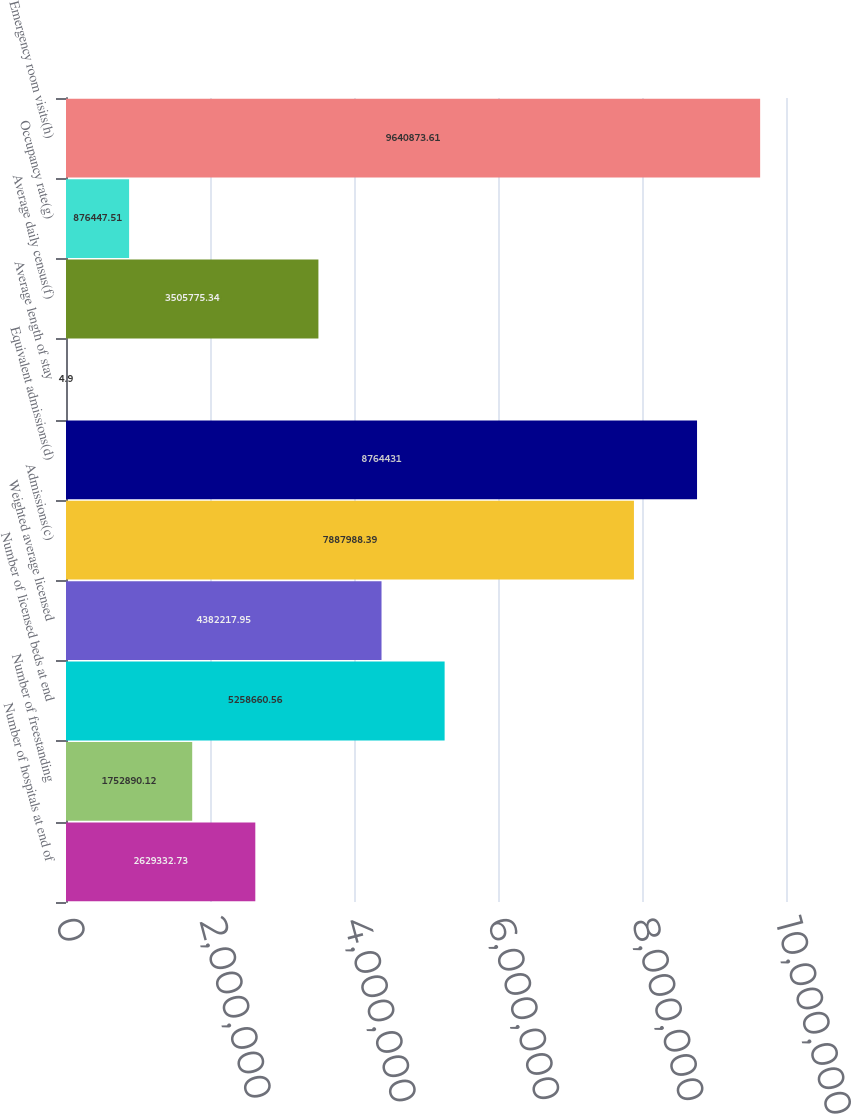<chart> <loc_0><loc_0><loc_500><loc_500><bar_chart><fcel>Number of hospitals at end of<fcel>Number of freestanding<fcel>Number of licensed beds at end<fcel>Weighted average licensed<fcel>Admissions(c)<fcel>Equivalent admissions(d)<fcel>Average length of stay<fcel>Average daily census(f)<fcel>Occupancy rate(g)<fcel>Emergency room visits(h)<nl><fcel>2.62933e+06<fcel>1.75289e+06<fcel>5.25866e+06<fcel>4.38222e+06<fcel>7.88799e+06<fcel>8.76443e+06<fcel>4.9<fcel>3.50578e+06<fcel>876448<fcel>9.64087e+06<nl></chart> 